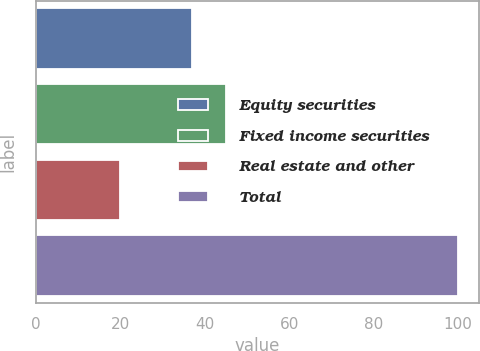Convert chart to OTSL. <chart><loc_0><loc_0><loc_500><loc_500><bar_chart><fcel>Equity securities<fcel>Fixed income securities<fcel>Real estate and other<fcel>Total<nl><fcel>37<fcel>45<fcel>20<fcel>100<nl></chart> 